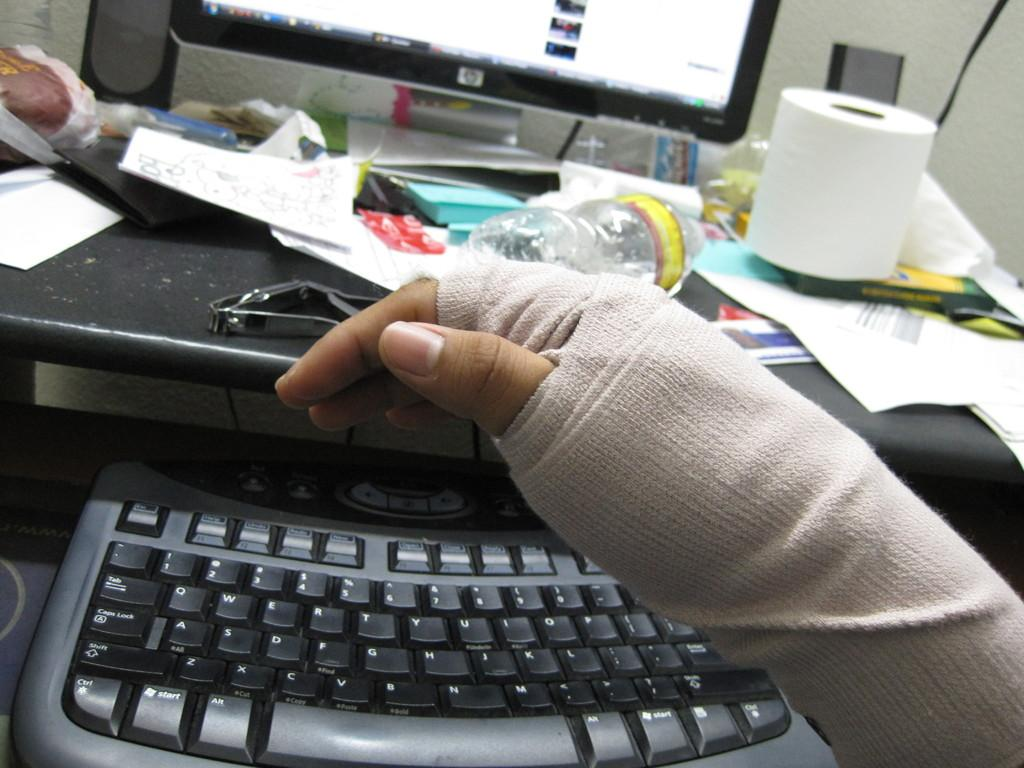Provide a one-sentence caption for the provided image. a bandaged hand in front of an HP computer monitor. 